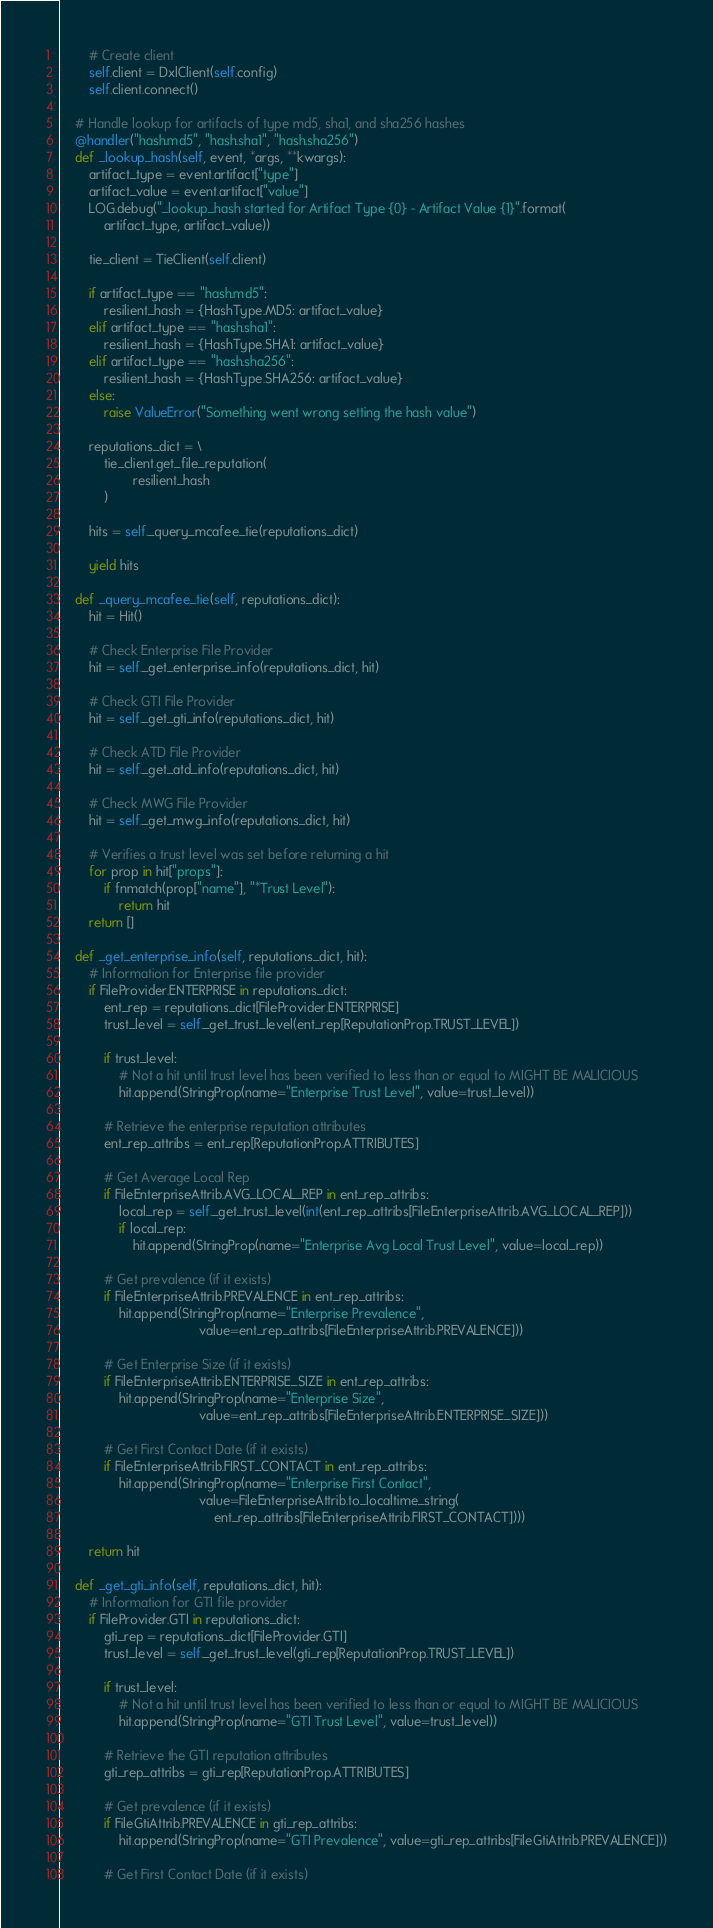Convert code to text. <code><loc_0><loc_0><loc_500><loc_500><_Python_>        # Create client
        self.client = DxlClient(self.config)
        self.client.connect()

    # Handle lookup for artifacts of type md5, sha1, and sha256 hashes
    @handler("hash.md5", "hash.sha1", "hash.sha256")
    def _lookup_hash(self, event, *args, **kwargs):
        artifact_type = event.artifact["type"]
        artifact_value = event.artifact["value"]
        LOG.debug("_lookup_hash started for Artifact Type {0} - Artifact Value {1}".format(
            artifact_type, artifact_value))

        tie_client = TieClient(self.client)

        if artifact_type == "hash.md5":
            resilient_hash = {HashType.MD5: artifact_value}
        elif artifact_type == "hash.sha1":
            resilient_hash = {HashType.SHA1: artifact_value}
        elif artifact_type == "hash.sha256":
            resilient_hash = {HashType.SHA256: artifact_value}
        else:
            raise ValueError("Something went wrong setting the hash value")

        reputations_dict = \
            tie_client.get_file_reputation(
                    resilient_hash
            )

        hits = self._query_mcafee_tie(reputations_dict)

        yield hits

    def _query_mcafee_tie(self, reputations_dict):
        hit = Hit()

        # Check Enterprise File Provider
        hit = self._get_enterprise_info(reputations_dict, hit)

        # Check GTI File Provider
        hit = self._get_gti_info(reputations_dict, hit)

        # Check ATD File Provider
        hit = self._get_atd_info(reputations_dict, hit)

        # Check MWG File Provider
        hit = self._get_mwg_info(reputations_dict, hit)

        # Verifies a trust level was set before returning a hit
        for prop in hit["props"]:
            if fnmatch(prop["name"], "*Trust Level"):
                return hit
        return []

    def _get_enterprise_info(self, reputations_dict, hit):
        # Information for Enterprise file provider
        if FileProvider.ENTERPRISE in reputations_dict:
            ent_rep = reputations_dict[FileProvider.ENTERPRISE]
            trust_level = self._get_trust_level(ent_rep[ReputationProp.TRUST_LEVEL])

            if trust_level:
                # Not a hit until trust level has been verified to less than or equal to MIGHT BE MALICIOUS
                hit.append(StringProp(name="Enterprise Trust Level", value=trust_level))

            # Retrieve the enterprise reputation attributes
            ent_rep_attribs = ent_rep[ReputationProp.ATTRIBUTES]

            # Get Average Local Rep
            if FileEnterpriseAttrib.AVG_LOCAL_REP in ent_rep_attribs:
                local_rep = self._get_trust_level(int(ent_rep_attribs[FileEnterpriseAttrib.AVG_LOCAL_REP]))
                if local_rep:
                    hit.append(StringProp(name="Enterprise Avg Local Trust Level", value=local_rep))

            # Get prevalence (if it exists)
            if FileEnterpriseAttrib.PREVALENCE in ent_rep_attribs:
                hit.append(StringProp(name="Enterprise Prevalence",
                                      value=ent_rep_attribs[FileEnterpriseAttrib.PREVALENCE]))

            # Get Enterprise Size (if it exists)
            if FileEnterpriseAttrib.ENTERPRISE_SIZE in ent_rep_attribs:
                hit.append(StringProp(name="Enterprise Size",
                                      value=ent_rep_attribs[FileEnterpriseAttrib.ENTERPRISE_SIZE]))

            # Get First Contact Date (if it exists)
            if FileEnterpriseAttrib.FIRST_CONTACT in ent_rep_attribs:
                hit.append(StringProp(name="Enterprise First Contact",
                                      value=FileEnterpriseAttrib.to_localtime_string(
                                          ent_rep_attribs[FileEnterpriseAttrib.FIRST_CONTACT])))

        return hit

    def _get_gti_info(self, reputations_dict, hit):
        # Information for GTI file provider
        if FileProvider.GTI in reputations_dict:
            gti_rep = reputations_dict[FileProvider.GTI]
            trust_level = self._get_trust_level(gti_rep[ReputationProp.TRUST_LEVEL])

            if trust_level:
                # Not a hit until trust level has been verified to less than or equal to MIGHT BE MALICIOUS
                hit.append(StringProp(name="GTI Trust Level", value=trust_level))

            # Retrieve the GTI reputation attributes
            gti_rep_attribs = gti_rep[ReputationProp.ATTRIBUTES]

            # Get prevalence (if it exists)
            if FileGtiAttrib.PREVALENCE in gti_rep_attribs:
                hit.append(StringProp(name="GTI Prevalence", value=gti_rep_attribs[FileGtiAttrib.PREVALENCE]))

            # Get First Contact Date (if it exists)</code> 